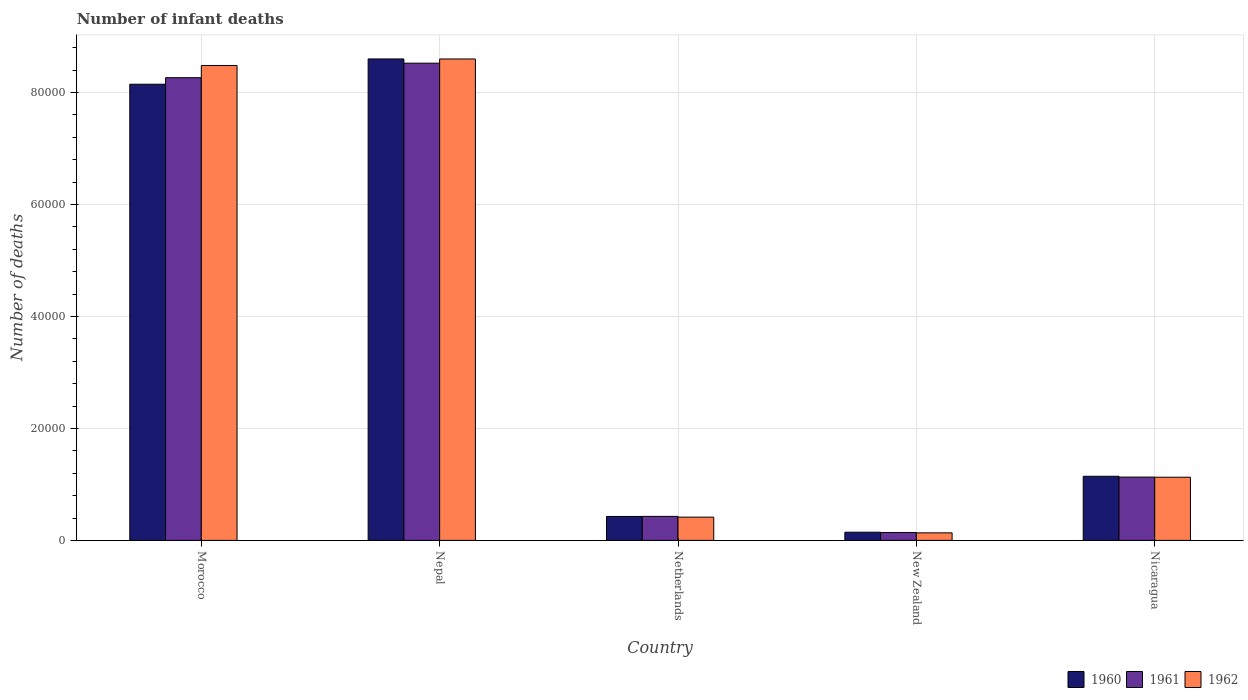How many groups of bars are there?
Your response must be concise. 5. Are the number of bars per tick equal to the number of legend labels?
Offer a very short reply. Yes. Are the number of bars on each tick of the X-axis equal?
Your answer should be very brief. Yes. What is the label of the 5th group of bars from the left?
Your response must be concise. Nicaragua. What is the number of infant deaths in 1960 in Nepal?
Your answer should be very brief. 8.60e+04. Across all countries, what is the maximum number of infant deaths in 1961?
Ensure brevity in your answer.  8.53e+04. Across all countries, what is the minimum number of infant deaths in 1961?
Give a very brief answer. 1412. In which country was the number of infant deaths in 1961 maximum?
Offer a terse response. Nepal. In which country was the number of infant deaths in 1961 minimum?
Keep it short and to the point. New Zealand. What is the total number of infant deaths in 1961 in the graph?
Provide a succinct answer. 1.85e+05. What is the difference between the number of infant deaths in 1962 in Morocco and that in Nepal?
Keep it short and to the point. -1161. What is the difference between the number of infant deaths in 1960 in Nicaragua and the number of infant deaths in 1962 in New Zealand?
Your response must be concise. 1.01e+04. What is the average number of infant deaths in 1960 per country?
Provide a short and direct response. 3.69e+04. What is the difference between the number of infant deaths of/in 1962 and number of infant deaths of/in 1961 in Morocco?
Your response must be concise. 2184. What is the ratio of the number of infant deaths in 1960 in Nepal to that in Nicaragua?
Your response must be concise. 7.51. Is the difference between the number of infant deaths in 1962 in Netherlands and Nicaragua greater than the difference between the number of infant deaths in 1961 in Netherlands and Nicaragua?
Provide a succinct answer. No. What is the difference between the highest and the second highest number of infant deaths in 1961?
Ensure brevity in your answer.  -7.14e+04. What is the difference between the highest and the lowest number of infant deaths in 1960?
Keep it short and to the point. 8.46e+04. In how many countries, is the number of infant deaths in 1960 greater than the average number of infant deaths in 1960 taken over all countries?
Your response must be concise. 2. Is the sum of the number of infant deaths in 1960 in Morocco and New Zealand greater than the maximum number of infant deaths in 1961 across all countries?
Offer a very short reply. No. What does the 3rd bar from the right in Morocco represents?
Your response must be concise. 1960. Is it the case that in every country, the sum of the number of infant deaths in 1961 and number of infant deaths in 1962 is greater than the number of infant deaths in 1960?
Ensure brevity in your answer.  Yes. Are all the bars in the graph horizontal?
Your response must be concise. No. How many countries are there in the graph?
Make the answer very short. 5. What is the difference between two consecutive major ticks on the Y-axis?
Your answer should be very brief. 2.00e+04. Are the values on the major ticks of Y-axis written in scientific E-notation?
Ensure brevity in your answer.  No. Does the graph contain grids?
Keep it short and to the point. Yes. How many legend labels are there?
Ensure brevity in your answer.  3. How are the legend labels stacked?
Your response must be concise. Horizontal. What is the title of the graph?
Provide a succinct answer. Number of infant deaths. Does "1996" appear as one of the legend labels in the graph?
Your answer should be very brief. No. What is the label or title of the X-axis?
Make the answer very short. Country. What is the label or title of the Y-axis?
Ensure brevity in your answer.  Number of deaths. What is the Number of deaths in 1960 in Morocco?
Provide a succinct answer. 8.15e+04. What is the Number of deaths in 1961 in Morocco?
Your answer should be very brief. 8.27e+04. What is the Number of deaths in 1962 in Morocco?
Ensure brevity in your answer.  8.48e+04. What is the Number of deaths in 1960 in Nepal?
Provide a succinct answer. 8.60e+04. What is the Number of deaths in 1961 in Nepal?
Offer a terse response. 8.53e+04. What is the Number of deaths in 1962 in Nepal?
Provide a short and direct response. 8.60e+04. What is the Number of deaths in 1960 in Netherlands?
Your answer should be compact. 4275. What is the Number of deaths in 1961 in Netherlands?
Give a very brief answer. 4288. What is the Number of deaths of 1962 in Netherlands?
Provide a short and direct response. 4155. What is the Number of deaths in 1960 in New Zealand?
Make the answer very short. 1461. What is the Number of deaths of 1961 in New Zealand?
Provide a short and direct response. 1412. What is the Number of deaths of 1962 in New Zealand?
Offer a terse response. 1346. What is the Number of deaths in 1960 in Nicaragua?
Your answer should be compact. 1.15e+04. What is the Number of deaths in 1961 in Nicaragua?
Make the answer very short. 1.13e+04. What is the Number of deaths of 1962 in Nicaragua?
Make the answer very short. 1.13e+04. Across all countries, what is the maximum Number of deaths in 1960?
Your response must be concise. 8.60e+04. Across all countries, what is the maximum Number of deaths of 1961?
Provide a succinct answer. 8.53e+04. Across all countries, what is the maximum Number of deaths in 1962?
Your response must be concise. 8.60e+04. Across all countries, what is the minimum Number of deaths of 1960?
Your response must be concise. 1461. Across all countries, what is the minimum Number of deaths of 1961?
Keep it short and to the point. 1412. Across all countries, what is the minimum Number of deaths of 1962?
Ensure brevity in your answer.  1346. What is the total Number of deaths in 1960 in the graph?
Offer a very short reply. 1.85e+05. What is the total Number of deaths of 1961 in the graph?
Ensure brevity in your answer.  1.85e+05. What is the total Number of deaths of 1962 in the graph?
Your answer should be very brief. 1.88e+05. What is the difference between the Number of deaths of 1960 in Morocco and that in Nepal?
Provide a short and direct response. -4516. What is the difference between the Number of deaths of 1961 in Morocco and that in Nepal?
Provide a short and direct response. -2593. What is the difference between the Number of deaths in 1962 in Morocco and that in Nepal?
Offer a terse response. -1161. What is the difference between the Number of deaths of 1960 in Morocco and that in Netherlands?
Offer a terse response. 7.72e+04. What is the difference between the Number of deaths in 1961 in Morocco and that in Netherlands?
Offer a very short reply. 7.84e+04. What is the difference between the Number of deaths in 1962 in Morocco and that in Netherlands?
Make the answer very short. 8.07e+04. What is the difference between the Number of deaths of 1960 in Morocco and that in New Zealand?
Offer a very short reply. 8.00e+04. What is the difference between the Number of deaths of 1961 in Morocco and that in New Zealand?
Offer a terse response. 8.12e+04. What is the difference between the Number of deaths in 1962 in Morocco and that in New Zealand?
Ensure brevity in your answer.  8.35e+04. What is the difference between the Number of deaths of 1960 in Morocco and that in Nicaragua?
Provide a short and direct response. 7.00e+04. What is the difference between the Number of deaths of 1961 in Morocco and that in Nicaragua?
Give a very brief answer. 7.14e+04. What is the difference between the Number of deaths in 1962 in Morocco and that in Nicaragua?
Make the answer very short. 7.36e+04. What is the difference between the Number of deaths in 1960 in Nepal and that in Netherlands?
Your response must be concise. 8.17e+04. What is the difference between the Number of deaths in 1961 in Nepal and that in Netherlands?
Your answer should be very brief. 8.10e+04. What is the difference between the Number of deaths in 1962 in Nepal and that in Netherlands?
Provide a short and direct response. 8.19e+04. What is the difference between the Number of deaths in 1960 in Nepal and that in New Zealand?
Your response must be concise. 8.46e+04. What is the difference between the Number of deaths of 1961 in Nepal and that in New Zealand?
Make the answer very short. 8.38e+04. What is the difference between the Number of deaths in 1962 in Nepal and that in New Zealand?
Provide a succinct answer. 8.47e+04. What is the difference between the Number of deaths of 1960 in Nepal and that in Nicaragua?
Offer a very short reply. 7.46e+04. What is the difference between the Number of deaths in 1961 in Nepal and that in Nicaragua?
Keep it short and to the point. 7.39e+04. What is the difference between the Number of deaths in 1962 in Nepal and that in Nicaragua?
Provide a short and direct response. 7.47e+04. What is the difference between the Number of deaths of 1960 in Netherlands and that in New Zealand?
Your answer should be compact. 2814. What is the difference between the Number of deaths of 1961 in Netherlands and that in New Zealand?
Provide a short and direct response. 2876. What is the difference between the Number of deaths of 1962 in Netherlands and that in New Zealand?
Make the answer very short. 2809. What is the difference between the Number of deaths of 1960 in Netherlands and that in Nicaragua?
Provide a succinct answer. -7179. What is the difference between the Number of deaths of 1961 in Netherlands and that in Nicaragua?
Provide a short and direct response. -7022. What is the difference between the Number of deaths of 1962 in Netherlands and that in Nicaragua?
Your answer should be compact. -7133. What is the difference between the Number of deaths in 1960 in New Zealand and that in Nicaragua?
Provide a short and direct response. -9993. What is the difference between the Number of deaths of 1961 in New Zealand and that in Nicaragua?
Your response must be concise. -9898. What is the difference between the Number of deaths in 1962 in New Zealand and that in Nicaragua?
Keep it short and to the point. -9942. What is the difference between the Number of deaths of 1960 in Morocco and the Number of deaths of 1961 in Nepal?
Offer a terse response. -3759. What is the difference between the Number of deaths of 1960 in Morocco and the Number of deaths of 1962 in Nepal?
Provide a succinct answer. -4511. What is the difference between the Number of deaths in 1961 in Morocco and the Number of deaths in 1962 in Nepal?
Keep it short and to the point. -3345. What is the difference between the Number of deaths in 1960 in Morocco and the Number of deaths in 1961 in Netherlands?
Make the answer very short. 7.72e+04. What is the difference between the Number of deaths of 1960 in Morocco and the Number of deaths of 1962 in Netherlands?
Ensure brevity in your answer.  7.73e+04. What is the difference between the Number of deaths of 1961 in Morocco and the Number of deaths of 1962 in Netherlands?
Make the answer very short. 7.85e+04. What is the difference between the Number of deaths of 1960 in Morocco and the Number of deaths of 1961 in New Zealand?
Offer a very short reply. 8.01e+04. What is the difference between the Number of deaths of 1960 in Morocco and the Number of deaths of 1962 in New Zealand?
Provide a succinct answer. 8.01e+04. What is the difference between the Number of deaths in 1961 in Morocco and the Number of deaths in 1962 in New Zealand?
Provide a succinct answer. 8.13e+04. What is the difference between the Number of deaths of 1960 in Morocco and the Number of deaths of 1961 in Nicaragua?
Keep it short and to the point. 7.02e+04. What is the difference between the Number of deaths in 1960 in Morocco and the Number of deaths in 1962 in Nicaragua?
Give a very brief answer. 7.02e+04. What is the difference between the Number of deaths of 1961 in Morocco and the Number of deaths of 1962 in Nicaragua?
Provide a short and direct response. 7.14e+04. What is the difference between the Number of deaths of 1960 in Nepal and the Number of deaths of 1961 in Netherlands?
Provide a succinct answer. 8.17e+04. What is the difference between the Number of deaths of 1960 in Nepal and the Number of deaths of 1962 in Netherlands?
Give a very brief answer. 8.19e+04. What is the difference between the Number of deaths in 1961 in Nepal and the Number of deaths in 1962 in Netherlands?
Give a very brief answer. 8.11e+04. What is the difference between the Number of deaths of 1960 in Nepal and the Number of deaths of 1961 in New Zealand?
Ensure brevity in your answer.  8.46e+04. What is the difference between the Number of deaths of 1960 in Nepal and the Number of deaths of 1962 in New Zealand?
Offer a terse response. 8.47e+04. What is the difference between the Number of deaths of 1961 in Nepal and the Number of deaths of 1962 in New Zealand?
Keep it short and to the point. 8.39e+04. What is the difference between the Number of deaths in 1960 in Nepal and the Number of deaths in 1961 in Nicaragua?
Provide a short and direct response. 7.47e+04. What is the difference between the Number of deaths in 1960 in Nepal and the Number of deaths in 1962 in Nicaragua?
Your response must be concise. 7.47e+04. What is the difference between the Number of deaths of 1961 in Nepal and the Number of deaths of 1962 in Nicaragua?
Keep it short and to the point. 7.40e+04. What is the difference between the Number of deaths in 1960 in Netherlands and the Number of deaths in 1961 in New Zealand?
Offer a very short reply. 2863. What is the difference between the Number of deaths of 1960 in Netherlands and the Number of deaths of 1962 in New Zealand?
Your answer should be very brief. 2929. What is the difference between the Number of deaths of 1961 in Netherlands and the Number of deaths of 1962 in New Zealand?
Make the answer very short. 2942. What is the difference between the Number of deaths in 1960 in Netherlands and the Number of deaths in 1961 in Nicaragua?
Your answer should be compact. -7035. What is the difference between the Number of deaths of 1960 in Netherlands and the Number of deaths of 1962 in Nicaragua?
Your answer should be very brief. -7013. What is the difference between the Number of deaths of 1961 in Netherlands and the Number of deaths of 1962 in Nicaragua?
Provide a short and direct response. -7000. What is the difference between the Number of deaths of 1960 in New Zealand and the Number of deaths of 1961 in Nicaragua?
Ensure brevity in your answer.  -9849. What is the difference between the Number of deaths of 1960 in New Zealand and the Number of deaths of 1962 in Nicaragua?
Your answer should be compact. -9827. What is the difference between the Number of deaths of 1961 in New Zealand and the Number of deaths of 1962 in Nicaragua?
Make the answer very short. -9876. What is the average Number of deaths in 1960 per country?
Your answer should be very brief. 3.69e+04. What is the average Number of deaths of 1961 per country?
Ensure brevity in your answer.  3.70e+04. What is the average Number of deaths in 1962 per country?
Your answer should be compact. 3.75e+04. What is the difference between the Number of deaths in 1960 and Number of deaths in 1961 in Morocco?
Keep it short and to the point. -1166. What is the difference between the Number of deaths in 1960 and Number of deaths in 1962 in Morocco?
Your answer should be very brief. -3350. What is the difference between the Number of deaths of 1961 and Number of deaths of 1962 in Morocco?
Your answer should be very brief. -2184. What is the difference between the Number of deaths in 1960 and Number of deaths in 1961 in Nepal?
Give a very brief answer. 757. What is the difference between the Number of deaths of 1960 and Number of deaths of 1962 in Nepal?
Ensure brevity in your answer.  5. What is the difference between the Number of deaths in 1961 and Number of deaths in 1962 in Nepal?
Your answer should be compact. -752. What is the difference between the Number of deaths in 1960 and Number of deaths in 1962 in Netherlands?
Offer a very short reply. 120. What is the difference between the Number of deaths in 1961 and Number of deaths in 1962 in Netherlands?
Ensure brevity in your answer.  133. What is the difference between the Number of deaths in 1960 and Number of deaths in 1961 in New Zealand?
Make the answer very short. 49. What is the difference between the Number of deaths of 1960 and Number of deaths of 1962 in New Zealand?
Offer a terse response. 115. What is the difference between the Number of deaths of 1960 and Number of deaths of 1961 in Nicaragua?
Provide a succinct answer. 144. What is the difference between the Number of deaths in 1960 and Number of deaths in 1962 in Nicaragua?
Offer a very short reply. 166. What is the difference between the Number of deaths in 1961 and Number of deaths in 1962 in Nicaragua?
Give a very brief answer. 22. What is the ratio of the Number of deaths in 1960 in Morocco to that in Nepal?
Your response must be concise. 0.95. What is the ratio of the Number of deaths of 1961 in Morocco to that in Nepal?
Provide a succinct answer. 0.97. What is the ratio of the Number of deaths in 1962 in Morocco to that in Nepal?
Give a very brief answer. 0.99. What is the ratio of the Number of deaths in 1960 in Morocco to that in Netherlands?
Your answer should be very brief. 19.06. What is the ratio of the Number of deaths of 1961 in Morocco to that in Netherlands?
Your answer should be very brief. 19.28. What is the ratio of the Number of deaths of 1962 in Morocco to that in Netherlands?
Offer a terse response. 20.42. What is the ratio of the Number of deaths in 1960 in Morocco to that in New Zealand?
Your response must be concise. 55.78. What is the ratio of the Number of deaths of 1961 in Morocco to that in New Zealand?
Keep it short and to the point. 58.54. What is the ratio of the Number of deaths of 1962 in Morocco to that in New Zealand?
Provide a short and direct response. 63.03. What is the ratio of the Number of deaths in 1960 in Morocco to that in Nicaragua?
Provide a succinct answer. 7.12. What is the ratio of the Number of deaths in 1961 in Morocco to that in Nicaragua?
Your response must be concise. 7.31. What is the ratio of the Number of deaths of 1962 in Morocco to that in Nicaragua?
Provide a short and direct response. 7.52. What is the ratio of the Number of deaths of 1960 in Nepal to that in Netherlands?
Your answer should be compact. 20.12. What is the ratio of the Number of deaths of 1961 in Nepal to that in Netherlands?
Provide a succinct answer. 19.88. What is the ratio of the Number of deaths of 1962 in Nepal to that in Netherlands?
Offer a very short reply. 20.7. What is the ratio of the Number of deaths of 1960 in Nepal to that in New Zealand?
Your answer should be very brief. 58.87. What is the ratio of the Number of deaths of 1961 in Nepal to that in New Zealand?
Make the answer very short. 60.38. What is the ratio of the Number of deaths in 1962 in Nepal to that in New Zealand?
Offer a terse response. 63.9. What is the ratio of the Number of deaths in 1960 in Nepal to that in Nicaragua?
Ensure brevity in your answer.  7.51. What is the ratio of the Number of deaths of 1961 in Nepal to that in Nicaragua?
Give a very brief answer. 7.54. What is the ratio of the Number of deaths of 1962 in Nepal to that in Nicaragua?
Ensure brevity in your answer.  7.62. What is the ratio of the Number of deaths of 1960 in Netherlands to that in New Zealand?
Offer a terse response. 2.93. What is the ratio of the Number of deaths of 1961 in Netherlands to that in New Zealand?
Keep it short and to the point. 3.04. What is the ratio of the Number of deaths in 1962 in Netherlands to that in New Zealand?
Ensure brevity in your answer.  3.09. What is the ratio of the Number of deaths of 1960 in Netherlands to that in Nicaragua?
Give a very brief answer. 0.37. What is the ratio of the Number of deaths of 1961 in Netherlands to that in Nicaragua?
Your response must be concise. 0.38. What is the ratio of the Number of deaths of 1962 in Netherlands to that in Nicaragua?
Ensure brevity in your answer.  0.37. What is the ratio of the Number of deaths in 1960 in New Zealand to that in Nicaragua?
Provide a short and direct response. 0.13. What is the ratio of the Number of deaths of 1961 in New Zealand to that in Nicaragua?
Your answer should be very brief. 0.12. What is the ratio of the Number of deaths of 1962 in New Zealand to that in Nicaragua?
Make the answer very short. 0.12. What is the difference between the highest and the second highest Number of deaths of 1960?
Provide a short and direct response. 4516. What is the difference between the highest and the second highest Number of deaths in 1961?
Ensure brevity in your answer.  2593. What is the difference between the highest and the second highest Number of deaths in 1962?
Offer a very short reply. 1161. What is the difference between the highest and the lowest Number of deaths in 1960?
Provide a succinct answer. 8.46e+04. What is the difference between the highest and the lowest Number of deaths of 1961?
Keep it short and to the point. 8.38e+04. What is the difference between the highest and the lowest Number of deaths of 1962?
Give a very brief answer. 8.47e+04. 